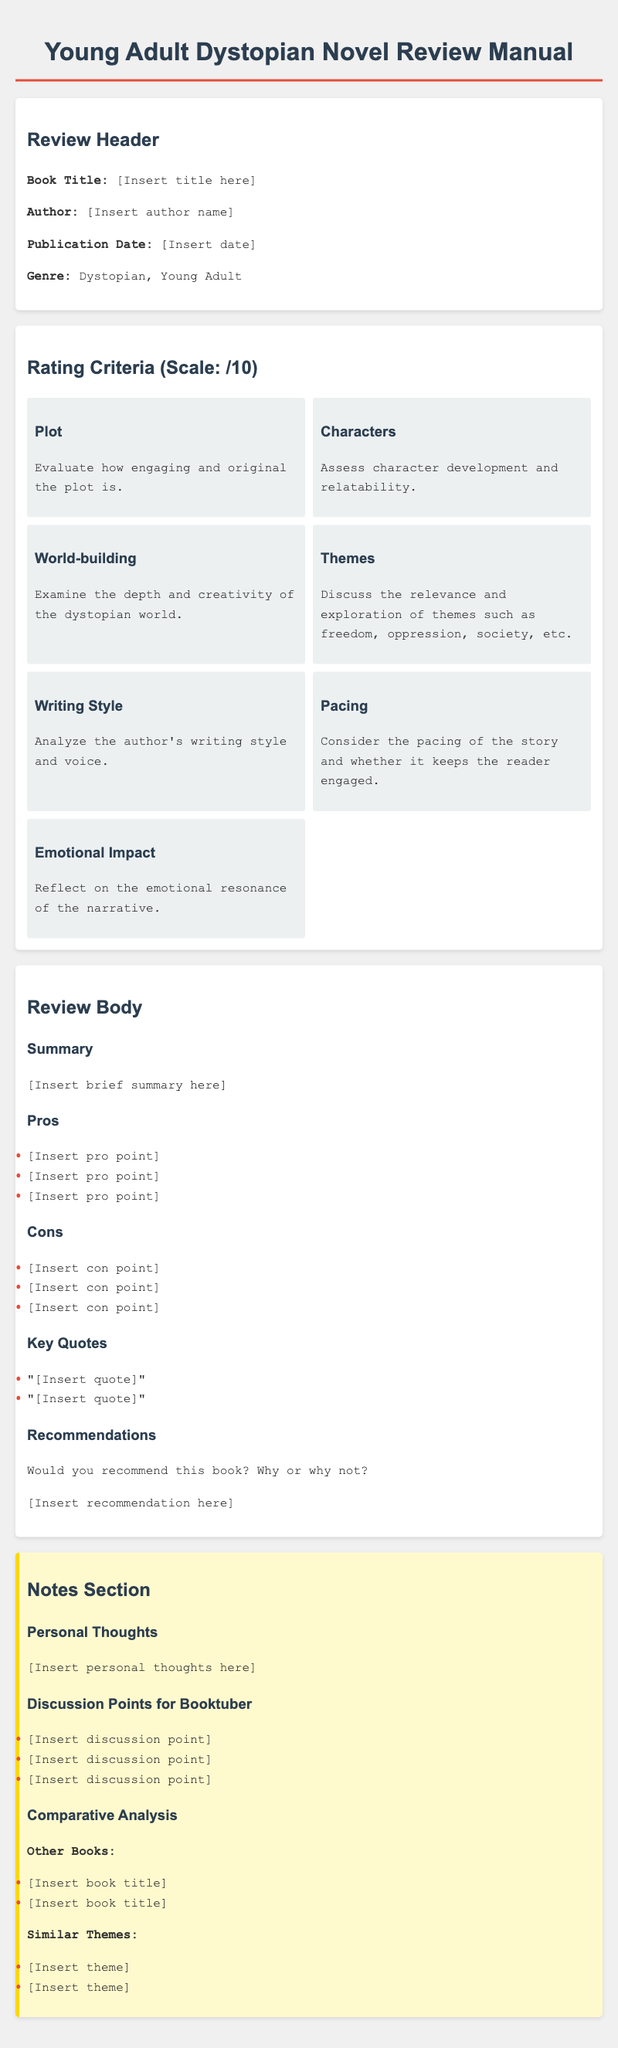What is the book genre mentioned? The document specifies the genre of the book as "Dystopian, Young Adult."
Answer: Dystopian, Young Adult What are the rating criteria used for the review? The document lists rating criteria such as Plot, Characters, World-building, Themes, Writing Style, Pacing, and Emotional Impact.
Answer: Plot, Characters, World-building, Themes, Writing Style, Pacing, Emotional Impact How many pros are suggested to list in the review? The document suggests listing three pros in the review.
Answer: Three What does the notes section include? The notes section includes Personal Thoughts, Discussion Points for Booktuber, and Comparative Analysis.
Answer: Personal Thoughts, Discussion Points for Booktuber, Comparative Analysis What is the recommended scale for rating? The manual indicates that the rating scale is out of 10.
Answer: /10 Which section follows the "Review Body"? After the "Review Body," the next section in the document is the "Notes Section."
Answer: Notes Section How many key quotes are suggested to include in the review? The document advises including two key quotes in the review.
Answer: Two What should be considered under "Pacing"? Pacing should consider the engagement level of the story throughout its progression.
Answer: Engagement What is mentioned as a theme to be explored in the review? The mention references themes such as freedom, oppression, and society.
Answer: Freedom, oppression, society 